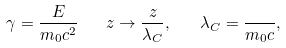<formula> <loc_0><loc_0><loc_500><loc_500>\gamma = \frac { E } { m _ { 0 } c ^ { 2 } } \quad z \rightarrow \frac { z } { \lambda _ { C } } , \quad \lambda _ { C } = \frac { } { m _ { 0 } c } ,</formula> 